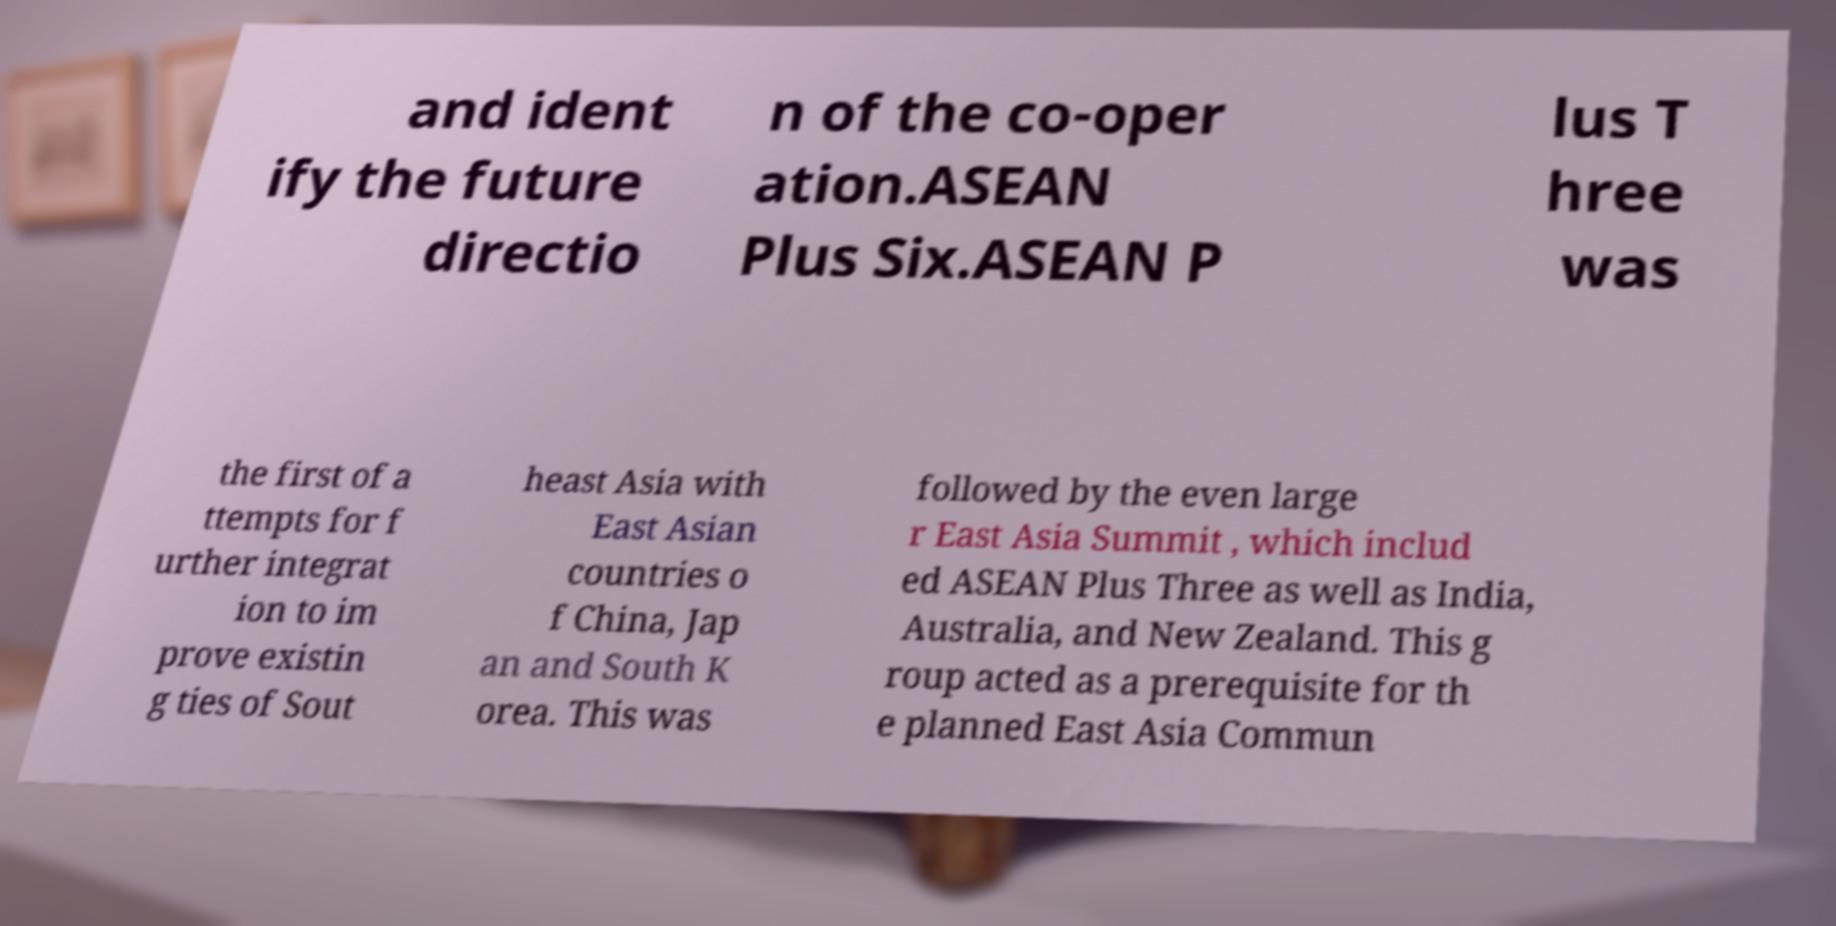For documentation purposes, I need the text within this image transcribed. Could you provide that? and ident ify the future directio n of the co-oper ation.ASEAN Plus Six.ASEAN P lus T hree was the first of a ttempts for f urther integrat ion to im prove existin g ties of Sout heast Asia with East Asian countries o f China, Jap an and South K orea. This was followed by the even large r East Asia Summit , which includ ed ASEAN Plus Three as well as India, Australia, and New Zealand. This g roup acted as a prerequisite for th e planned East Asia Commun 